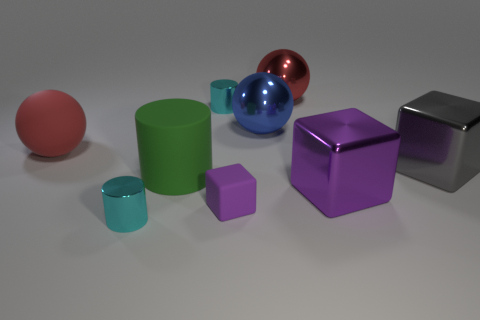What is the size of the cyan object to the right of the small cylinder that is in front of the tiny purple matte cube?
Your answer should be compact. Small. Is the color of the small metal thing in front of the large blue shiny ball the same as the large metallic cube that is in front of the gray object?
Ensure brevity in your answer.  No. The object that is left of the large green rubber object and in front of the gray object is what color?
Provide a succinct answer. Cyan. How many other objects are there of the same shape as the large green matte object?
Your answer should be very brief. 2. The metallic block that is the same size as the gray metal thing is what color?
Offer a terse response. Purple. There is a ball that is on the left side of the tiny purple object; what color is it?
Ensure brevity in your answer.  Red. There is a cyan shiny cylinder that is behind the blue object; are there any large cubes to the right of it?
Your answer should be compact. Yes. Is the shape of the big red shiny thing the same as the metallic thing to the right of the big purple cube?
Your response must be concise. No. What size is the metal object that is to the right of the big green cylinder and on the left side of the tiny purple object?
Make the answer very short. Small. Is there a cyan ball that has the same material as the large blue sphere?
Provide a succinct answer. No. 